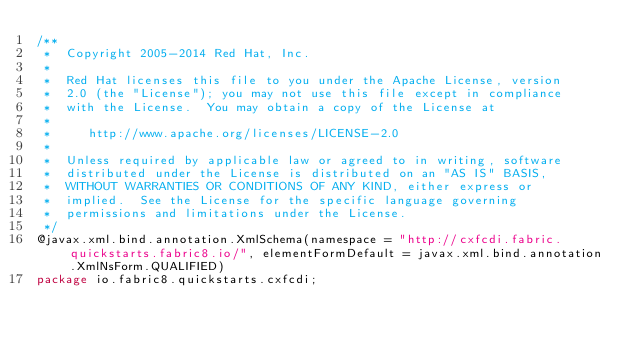Convert code to text. <code><loc_0><loc_0><loc_500><loc_500><_Java_>/**
 *  Copyright 2005-2014 Red Hat, Inc.
 *
 *  Red Hat licenses this file to you under the Apache License, version
 *  2.0 (the "License"); you may not use this file except in compliance
 *  with the License.  You may obtain a copy of the License at
 *
 *     http://www.apache.org/licenses/LICENSE-2.0
 *
 *  Unless required by applicable law or agreed to in writing, software
 *  distributed under the License is distributed on an "AS IS" BASIS,
 *  WITHOUT WARRANTIES OR CONDITIONS OF ANY KIND, either express or
 *  implied.  See the License for the specific language governing
 *  permissions and limitations under the License.
 */
@javax.xml.bind.annotation.XmlSchema(namespace = "http://cxfcdi.fabric.quickstarts.fabric8.io/", elementFormDefault = javax.xml.bind.annotation.XmlNsForm.QUALIFIED)
package io.fabric8.quickstarts.cxfcdi;

</code> 